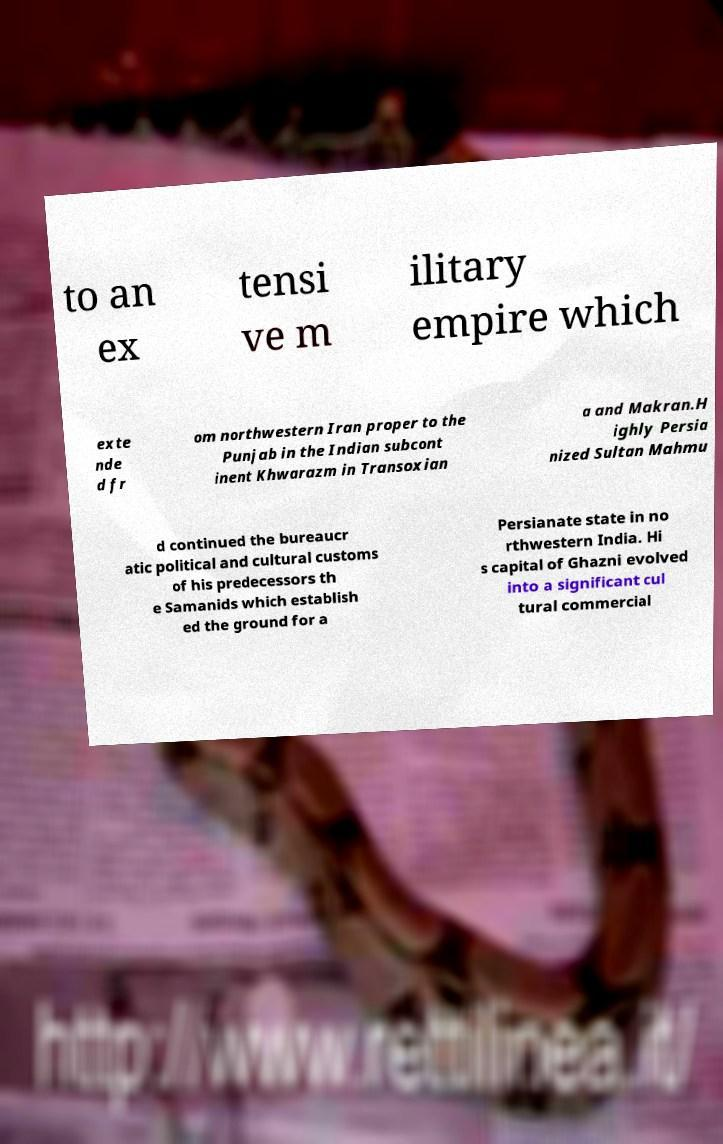Could you assist in decoding the text presented in this image and type it out clearly? to an ex tensi ve m ilitary empire which exte nde d fr om northwestern Iran proper to the Punjab in the Indian subcont inent Khwarazm in Transoxian a and Makran.H ighly Persia nized Sultan Mahmu d continued the bureaucr atic political and cultural customs of his predecessors th e Samanids which establish ed the ground for a Persianate state in no rthwestern India. Hi s capital of Ghazni evolved into a significant cul tural commercial 